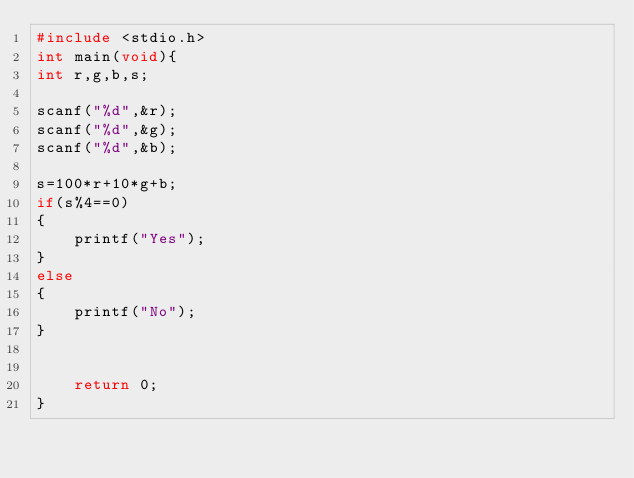Convert code to text. <code><loc_0><loc_0><loc_500><loc_500><_C_>#include <stdio.h>
int main(void){
int r,g,b,s;

scanf("%d",&r);
scanf("%d",&g);
scanf("%d",&b);

s=100*r+10*g+b;
if(s%4==0)
{
    printf("Yes");
}
else
{
    printf("No");
}


    return 0;
}</code> 